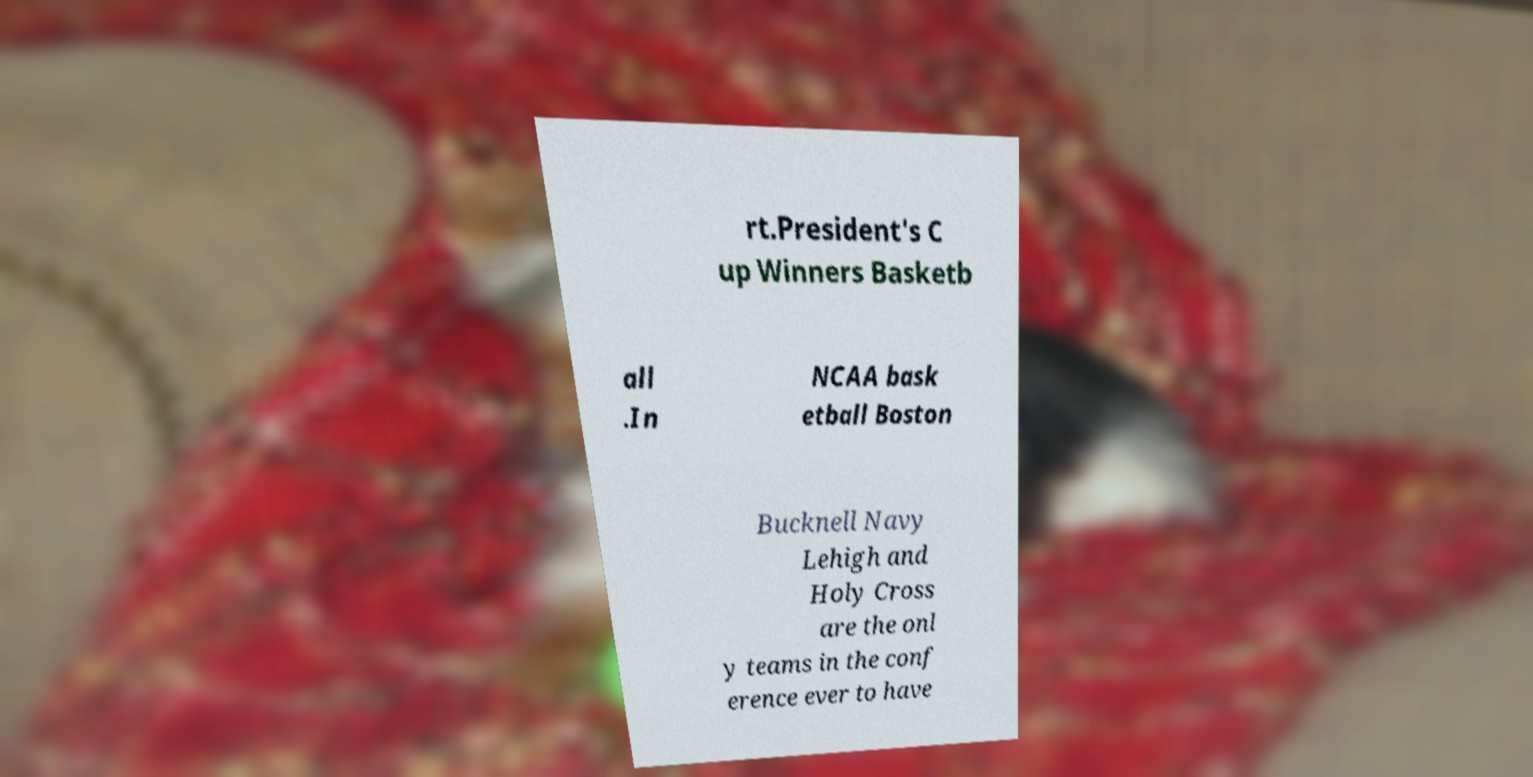For documentation purposes, I need the text within this image transcribed. Could you provide that? rt.President's C up Winners Basketb all .In NCAA bask etball Boston Bucknell Navy Lehigh and Holy Cross are the onl y teams in the conf erence ever to have 